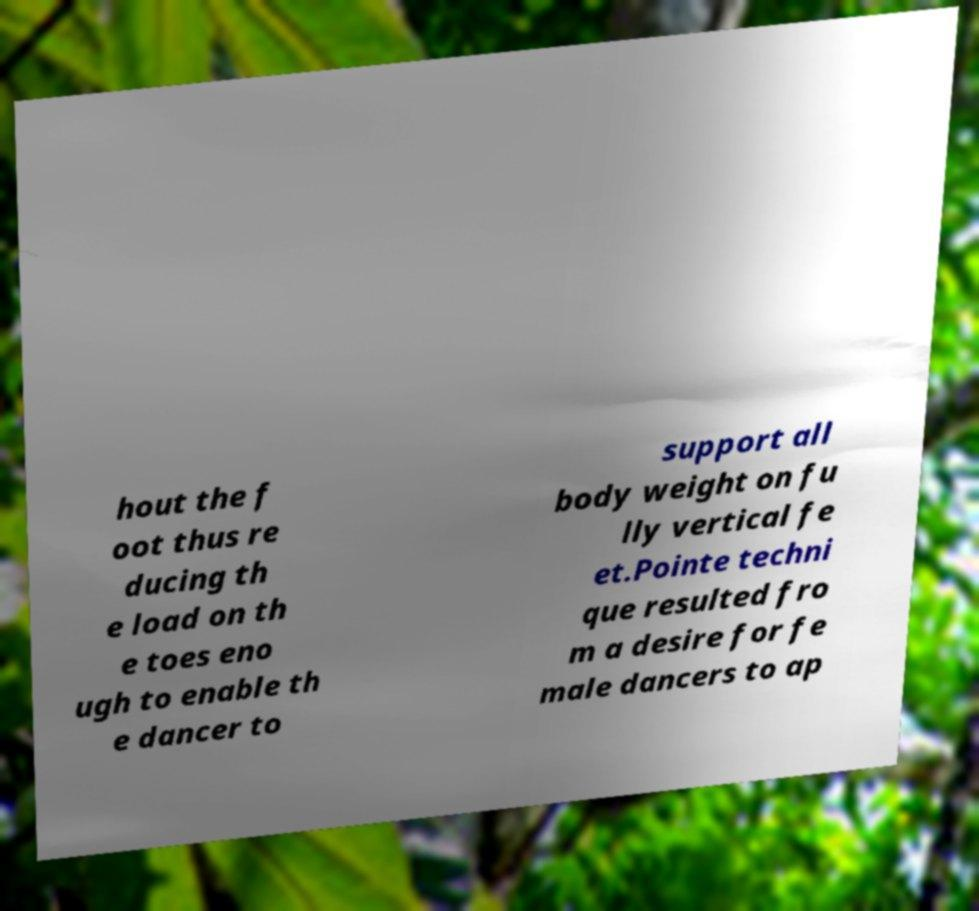Please identify and transcribe the text found in this image. hout the f oot thus re ducing th e load on th e toes eno ugh to enable th e dancer to support all body weight on fu lly vertical fe et.Pointe techni que resulted fro m a desire for fe male dancers to ap 